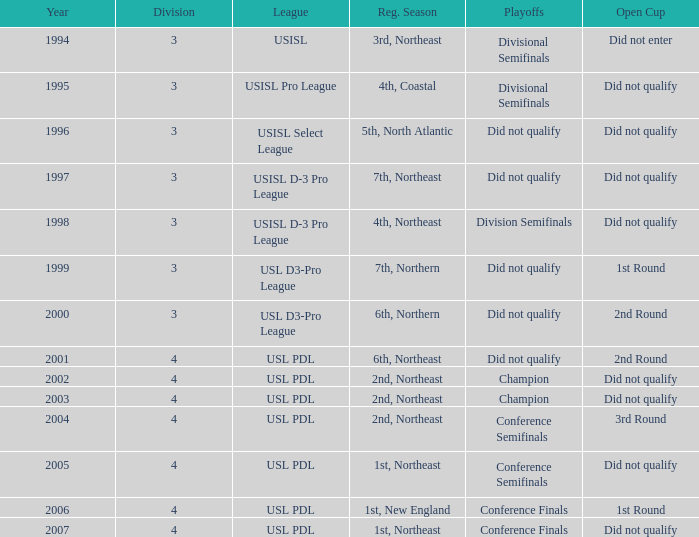Specify the normal season for 200 6th, Northeast. 